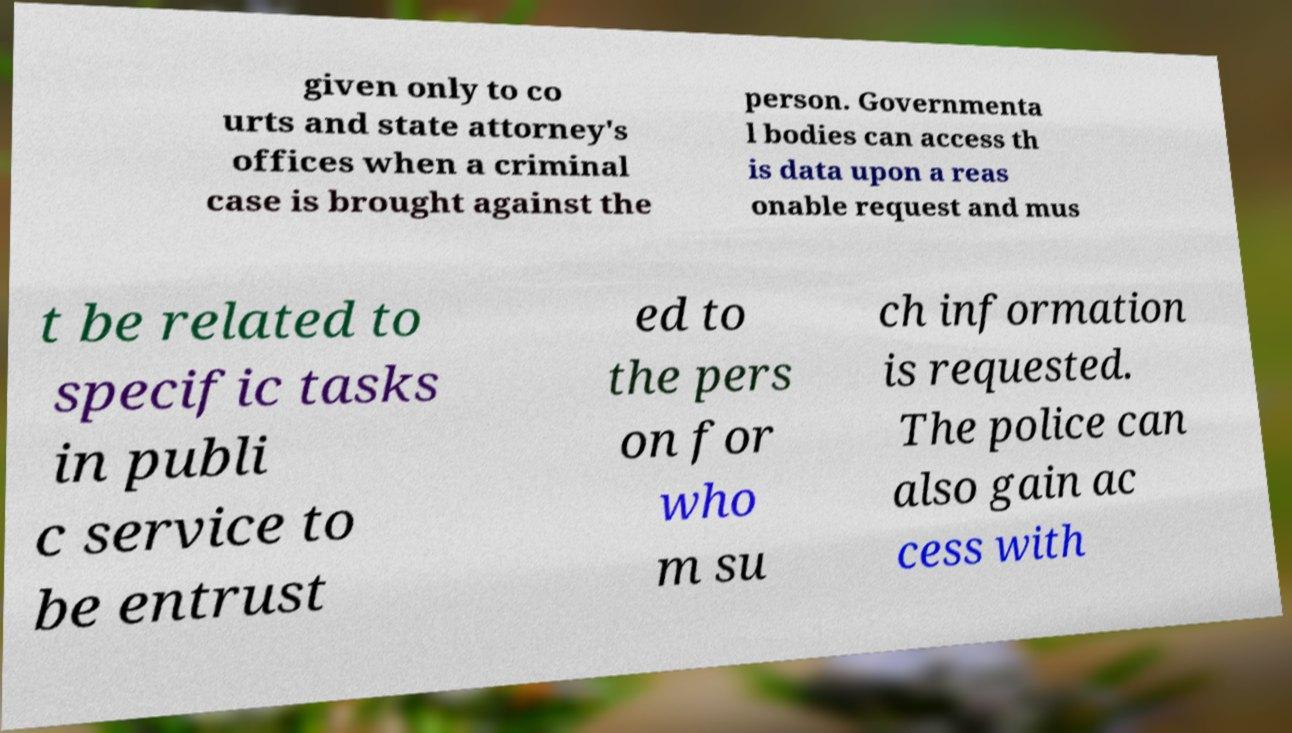Please read and relay the text visible in this image. What does it say? given only to co urts and state attorney's offices when a criminal case is brought against the person. Governmenta l bodies can access th is data upon a reas onable request and mus t be related to specific tasks in publi c service to be entrust ed to the pers on for who m su ch information is requested. The police can also gain ac cess with 